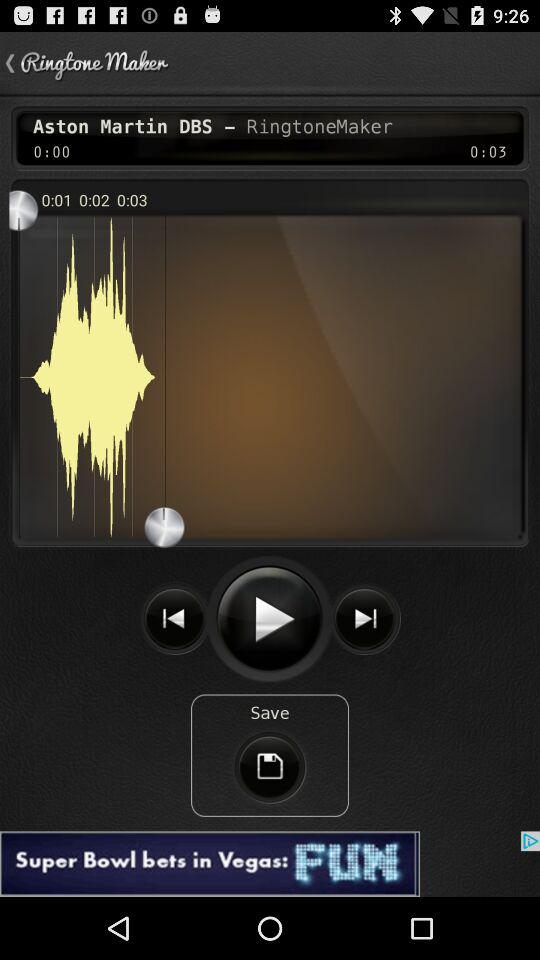What is the name of the song edited in "RingtoneMaker"? The name of the song is "Aston Martin DBS". 